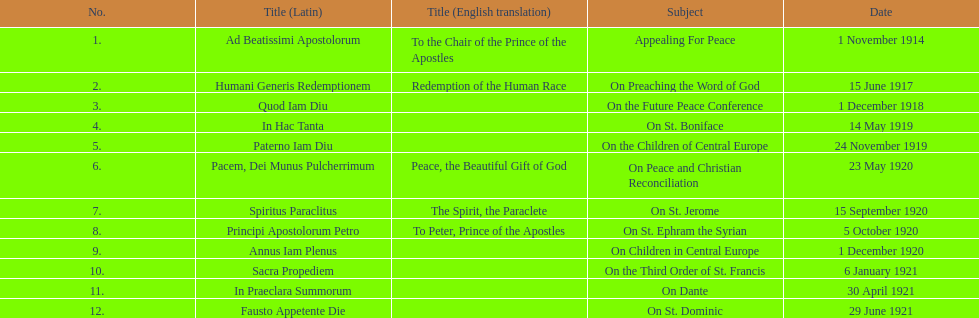Apart from january, how many encyclicals existed in 1921? 2. 